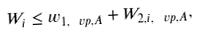Convert formula to latex. <formula><loc_0><loc_0><loc_500><loc_500>W _ { i } \leq w _ { 1 , \ v p , A } + W _ { 2 , i , \ v p , A } ,</formula> 